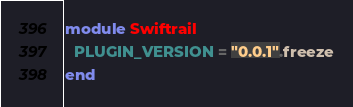Convert code to text. <code><loc_0><loc_0><loc_500><loc_500><_Ruby_>module Swiftrail
  PLUGIN_VERSION = "0.0.1".freeze
end
</code> 